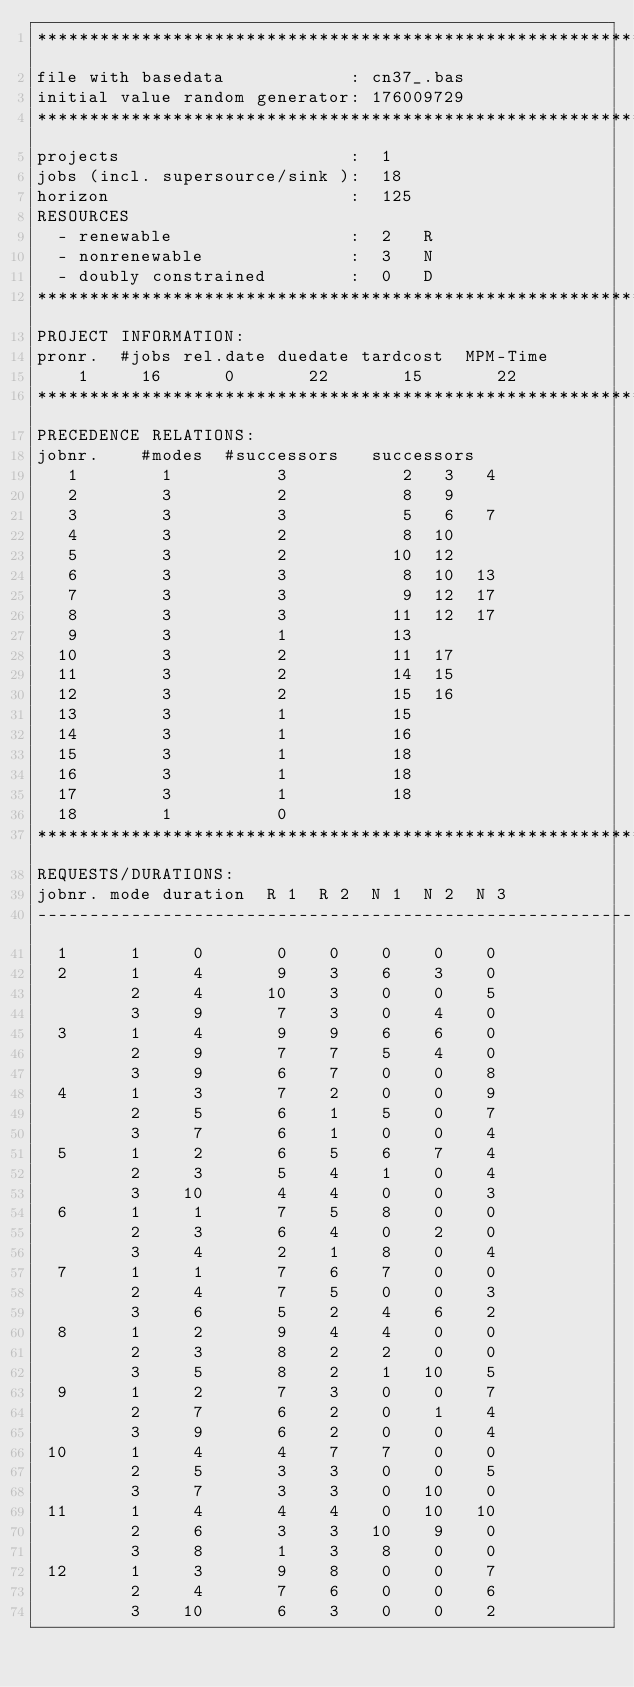<code> <loc_0><loc_0><loc_500><loc_500><_ObjectiveC_>************************************************************************
file with basedata            : cn37_.bas
initial value random generator: 176009729
************************************************************************
projects                      :  1
jobs (incl. supersource/sink ):  18
horizon                       :  125
RESOURCES
  - renewable                 :  2   R
  - nonrenewable              :  3   N
  - doubly constrained        :  0   D
************************************************************************
PROJECT INFORMATION:
pronr.  #jobs rel.date duedate tardcost  MPM-Time
    1     16      0       22       15       22
************************************************************************
PRECEDENCE RELATIONS:
jobnr.    #modes  #successors   successors
   1        1          3           2   3   4
   2        3          2           8   9
   3        3          3           5   6   7
   4        3          2           8  10
   5        3          2          10  12
   6        3          3           8  10  13
   7        3          3           9  12  17
   8        3          3          11  12  17
   9        3          1          13
  10        3          2          11  17
  11        3          2          14  15
  12        3          2          15  16
  13        3          1          15
  14        3          1          16
  15        3          1          18
  16        3          1          18
  17        3          1          18
  18        1          0        
************************************************************************
REQUESTS/DURATIONS:
jobnr. mode duration  R 1  R 2  N 1  N 2  N 3
------------------------------------------------------------------------
  1      1     0       0    0    0    0    0
  2      1     4       9    3    6    3    0
         2     4      10    3    0    0    5
         3     9       7    3    0    4    0
  3      1     4       9    9    6    6    0
         2     9       7    7    5    4    0
         3     9       6    7    0    0    8
  4      1     3       7    2    0    0    9
         2     5       6    1    5    0    7
         3     7       6    1    0    0    4
  5      1     2       6    5    6    7    4
         2     3       5    4    1    0    4
         3    10       4    4    0    0    3
  6      1     1       7    5    8    0    0
         2     3       6    4    0    2    0
         3     4       2    1    8    0    4
  7      1     1       7    6    7    0    0
         2     4       7    5    0    0    3
         3     6       5    2    4    6    2
  8      1     2       9    4    4    0    0
         2     3       8    2    2    0    0
         3     5       8    2    1   10    5
  9      1     2       7    3    0    0    7
         2     7       6    2    0    1    4
         3     9       6    2    0    0    4
 10      1     4       4    7    7    0    0
         2     5       3    3    0    0    5
         3     7       3    3    0   10    0
 11      1     4       4    4    0   10   10
         2     6       3    3   10    9    0
         3     8       1    3    8    0    0
 12      1     3       9    8    0    0    7
         2     4       7    6    0    0    6
         3    10       6    3    0    0    2</code> 